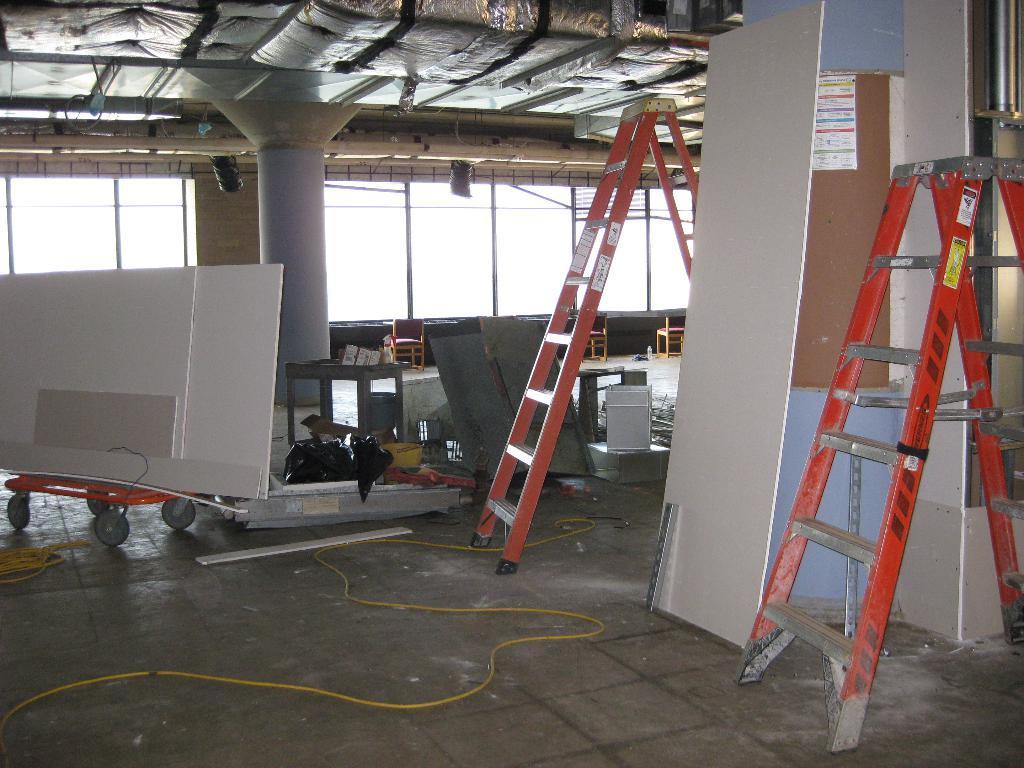Could you give a brief overview of what you see in this image? In the picture I can see ladders, boards, a pillar and some other objects on the floor. In the background I can see framed glass wall, ceiling and some other objects. 